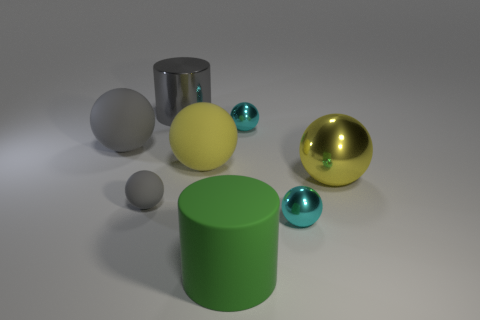There is a yellow rubber object; does it have the same size as the cylinder that is to the left of the large yellow matte sphere?
Make the answer very short. Yes. The rubber object that is behind the small gray object and on the left side of the gray metallic cylinder is what color?
Your response must be concise. Gray. How many objects are either large objects that are behind the small gray matte thing or small cyan metal things in front of the big gray matte object?
Keep it short and to the point. 5. What is the color of the cylinder that is behind the rubber cylinder that is in front of the large gray metallic cylinder that is left of the yellow metal thing?
Make the answer very short. Gray. Are there any other things that have the same shape as the large yellow metallic thing?
Provide a short and direct response. Yes. How many tiny cyan shiny things are there?
Give a very brief answer. 2. The small gray thing is what shape?
Offer a terse response. Sphere. What number of other cylinders have the same size as the rubber cylinder?
Your answer should be very brief. 1. Does the big yellow metal object have the same shape as the large gray shiny object?
Provide a succinct answer. No. There is a rubber object in front of the cyan shiny ball that is in front of the large gray ball; what is its color?
Provide a short and direct response. Green. 